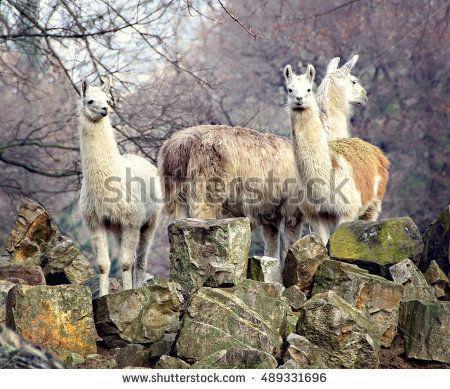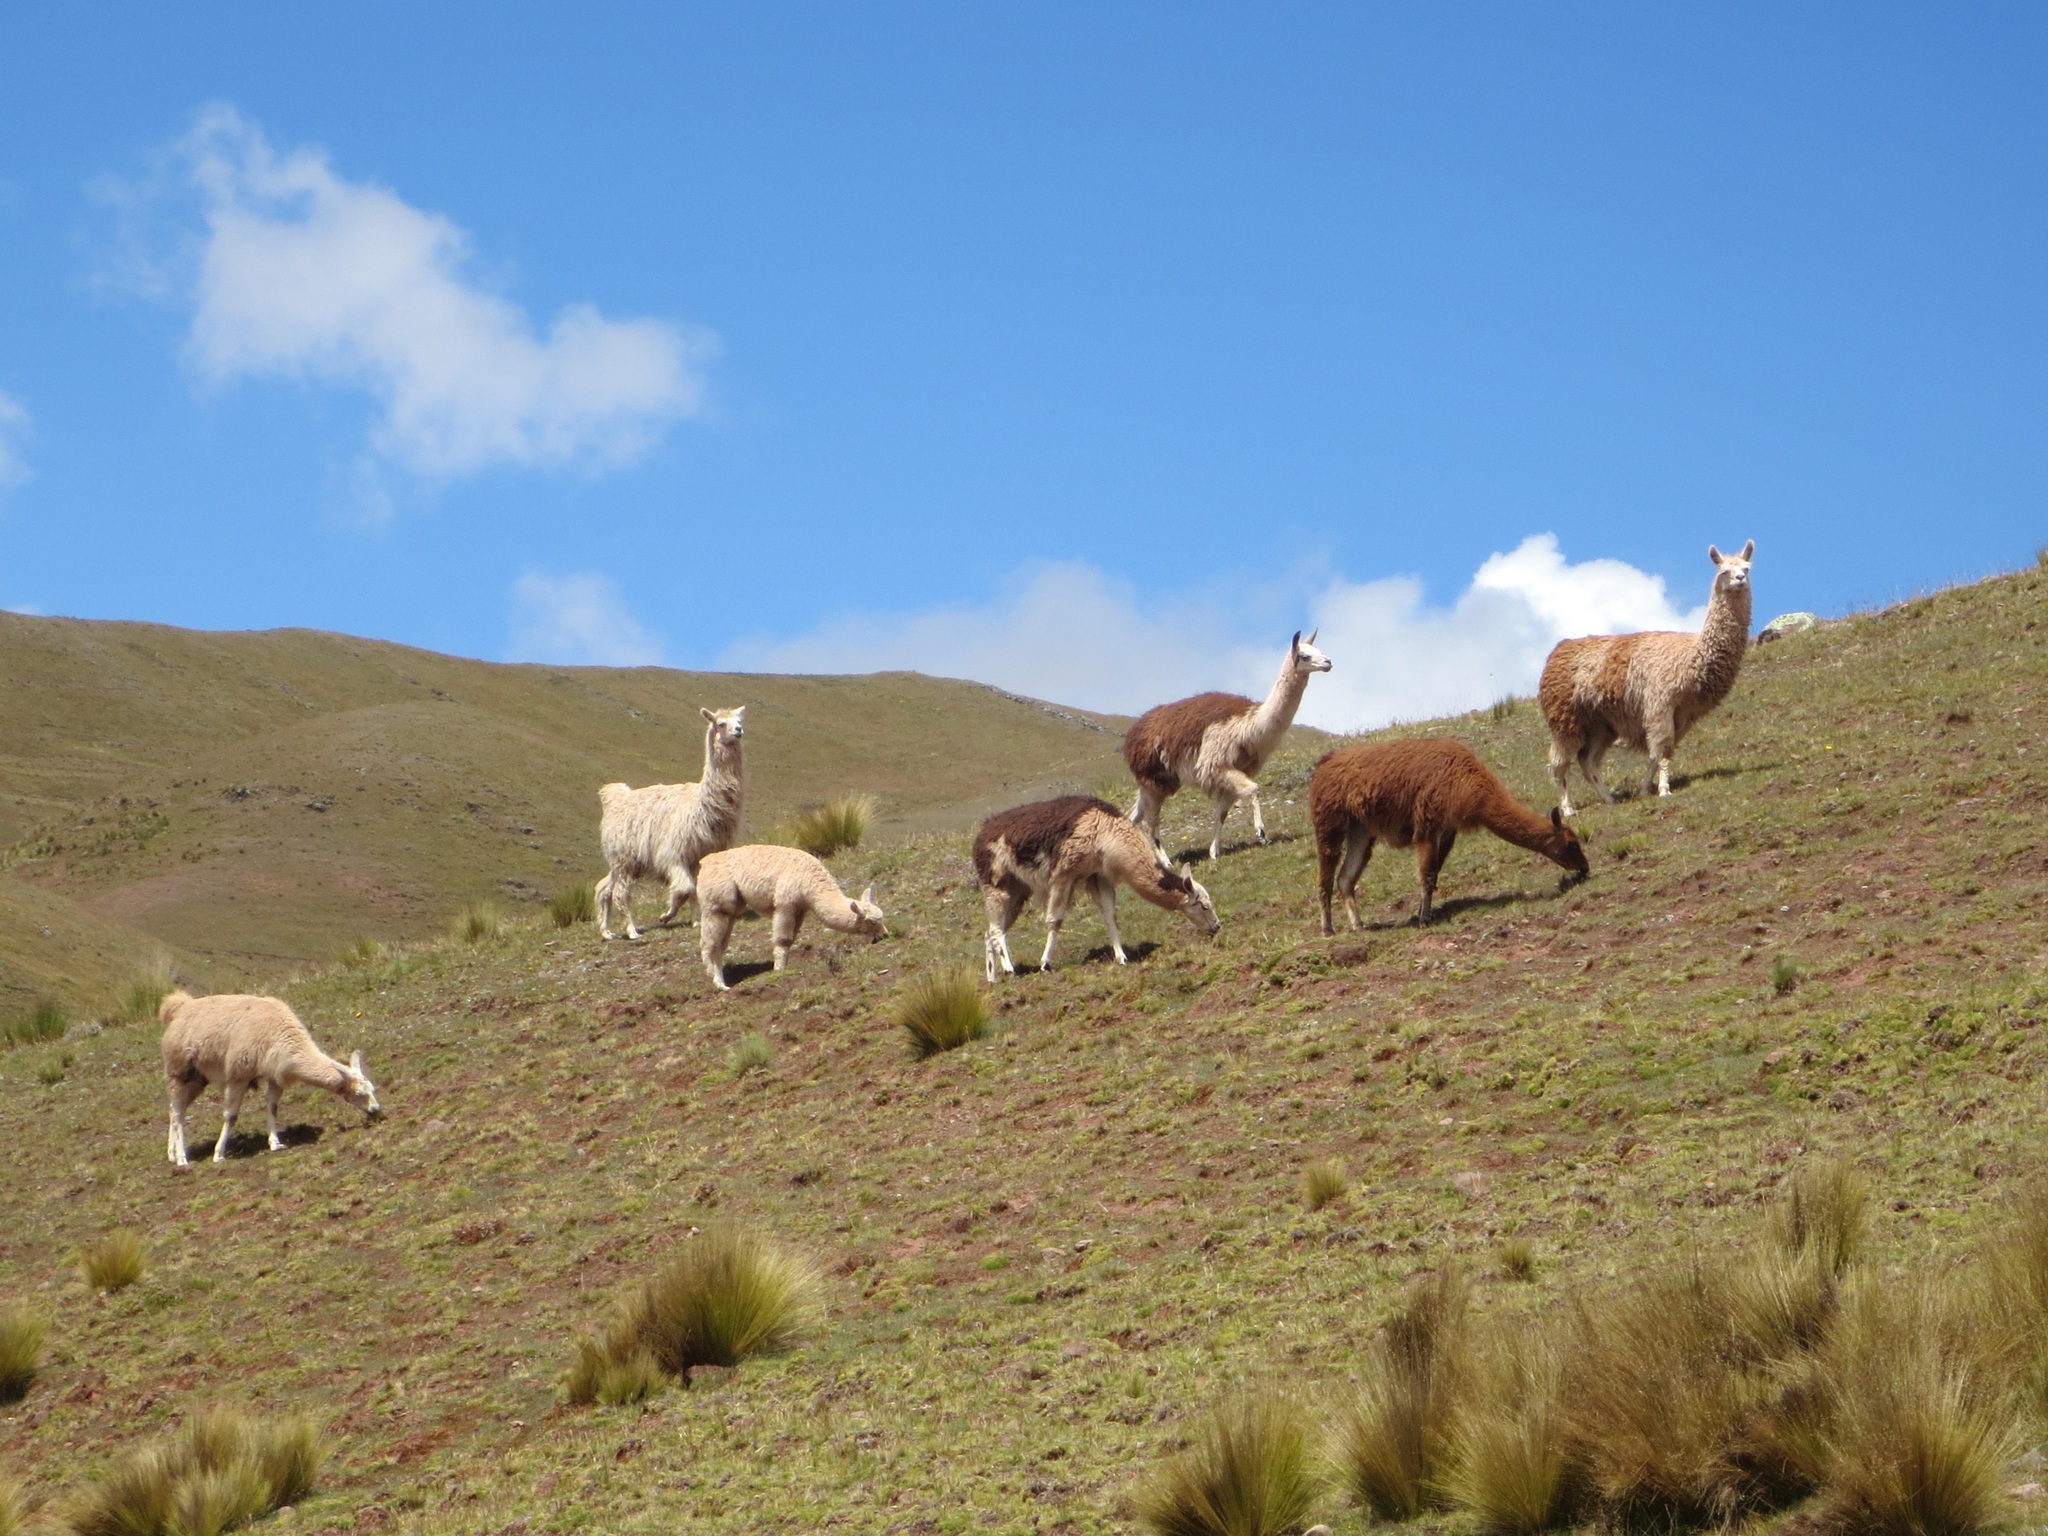The first image is the image on the left, the second image is the image on the right. For the images displayed, is the sentence "There are at least three llamas walking forward over big rocks." factually correct? Answer yes or no. Yes. The first image is the image on the left, the second image is the image on the right. For the images displayed, is the sentence "The left image shows a small group of different colored llamas who aren't wearing anything, and the right image inludes at least one rightward-facing llama who is grazing." factually correct? Answer yes or no. Yes. 